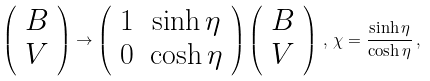Convert formula to latex. <formula><loc_0><loc_0><loc_500><loc_500>\left ( \begin{array} [ c ] { c } B \\ V \end{array} \right ) \rightarrow \left ( \begin{array} [ c ] { c c } 1 & \sinh \eta \\ 0 & \cosh \eta \end{array} \right ) \left ( \begin{array} [ c ] { c } B \\ V \end{array} \right ) \, , \, \chi = \frac { \sinh \eta } { \cosh \eta } \, ,</formula> 